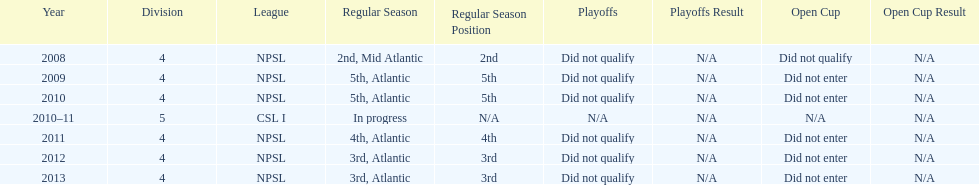What was the last year they came in 3rd place 2013. 